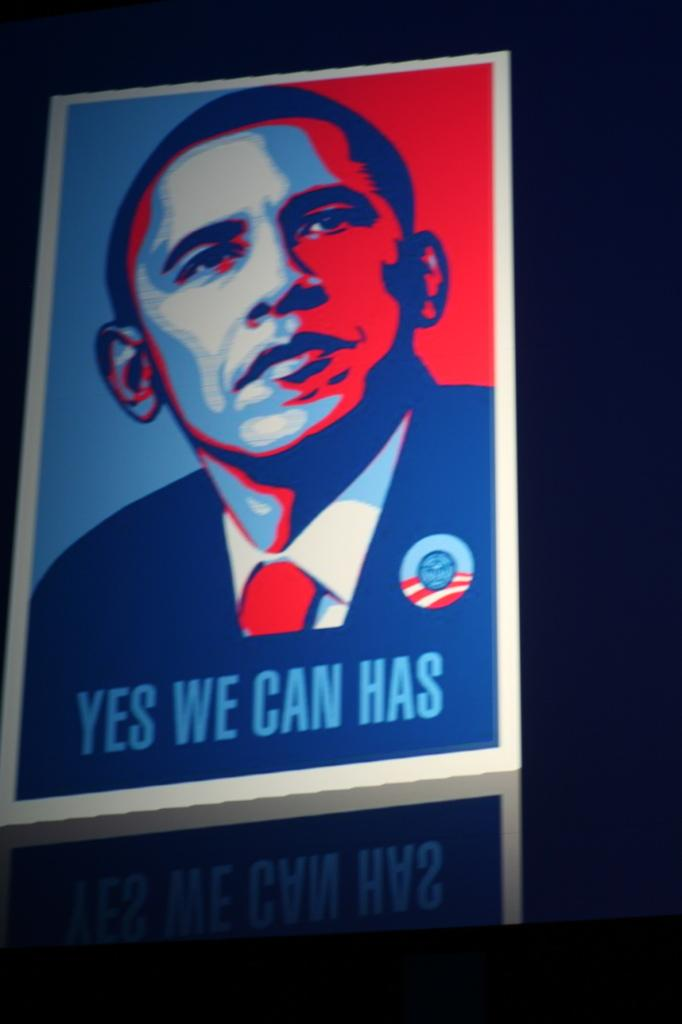<image>
Relay a brief, clear account of the picture shown. A poster of former president barack obama that reads "Yes we can has". 